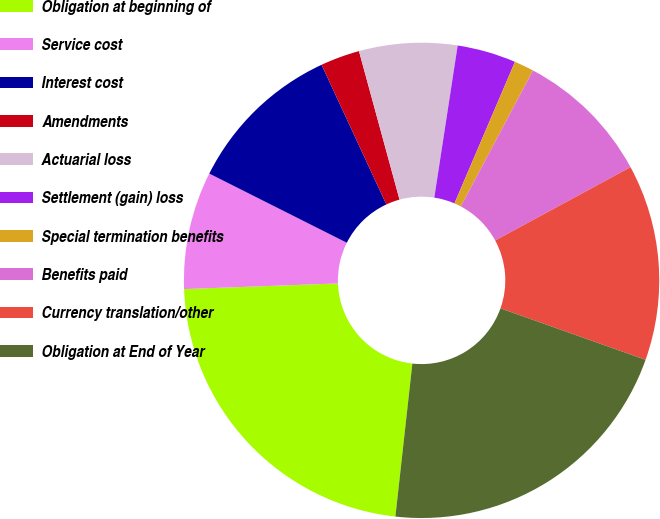Convert chart. <chart><loc_0><loc_0><loc_500><loc_500><pie_chart><fcel>Obligation at beginning of<fcel>Service cost<fcel>Interest cost<fcel>Amendments<fcel>Actuarial loss<fcel>Settlement (gain) loss<fcel>Special termination benefits<fcel>Benefits paid<fcel>Currency translation/other<fcel>Obligation at End of Year<nl><fcel>22.66%<fcel>8.0%<fcel>10.67%<fcel>2.67%<fcel>6.67%<fcel>4.0%<fcel>1.34%<fcel>9.33%<fcel>13.33%<fcel>21.33%<nl></chart> 